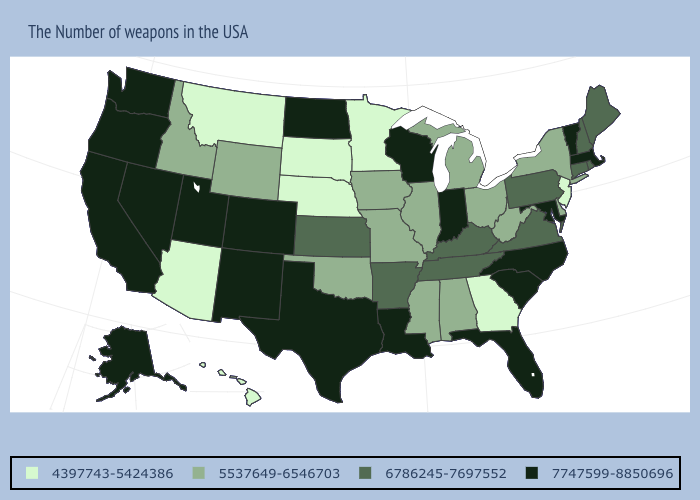Among the states that border Iowa , which have the lowest value?
Concise answer only. Minnesota, Nebraska, South Dakota. Does Utah have a higher value than Illinois?
Concise answer only. Yes. What is the highest value in the USA?
Short answer required. 7747599-8850696. Name the states that have a value in the range 5537649-6546703?
Short answer required. New York, Delaware, West Virginia, Ohio, Michigan, Alabama, Illinois, Mississippi, Missouri, Iowa, Oklahoma, Wyoming, Idaho. Name the states that have a value in the range 4397743-5424386?
Concise answer only. New Jersey, Georgia, Minnesota, Nebraska, South Dakota, Montana, Arizona, Hawaii. What is the value of Texas?
Be succinct. 7747599-8850696. Does Arkansas have the highest value in the USA?
Concise answer only. No. What is the value of New Jersey?
Quick response, please. 4397743-5424386. What is the lowest value in the Northeast?
Be succinct. 4397743-5424386. What is the value of Washington?
Write a very short answer. 7747599-8850696. Does Massachusetts have the lowest value in the USA?
Be succinct. No. Which states have the lowest value in the South?
Quick response, please. Georgia. What is the value of Rhode Island?
Answer briefly. 6786245-7697552. What is the value of North Dakota?
Give a very brief answer. 7747599-8850696. Among the states that border Texas , which have the highest value?
Quick response, please. Louisiana, New Mexico. 